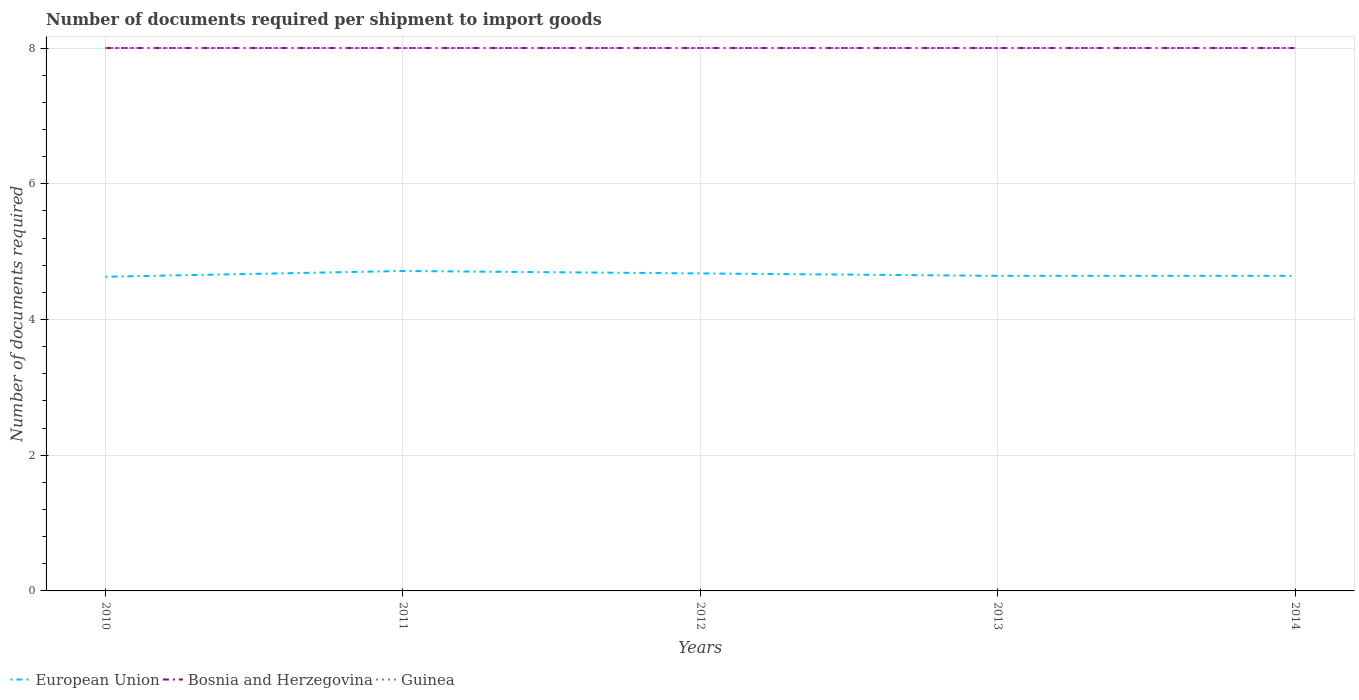Is the number of lines equal to the number of legend labels?
Make the answer very short. Yes. Across all years, what is the maximum number of documents required per shipment to import goods in Guinea?
Your response must be concise. 8. In which year was the number of documents required per shipment to import goods in Bosnia and Herzegovina maximum?
Your response must be concise. 2010. What is the total number of documents required per shipment to import goods in European Union in the graph?
Make the answer very short. -0.01. What is the difference between the highest and the second highest number of documents required per shipment to import goods in Bosnia and Herzegovina?
Offer a terse response. 0. What is the difference between the highest and the lowest number of documents required per shipment to import goods in Bosnia and Herzegovina?
Offer a terse response. 0. Is the number of documents required per shipment to import goods in Bosnia and Herzegovina strictly greater than the number of documents required per shipment to import goods in Guinea over the years?
Provide a succinct answer. No. How many lines are there?
Ensure brevity in your answer.  3. How many years are there in the graph?
Offer a very short reply. 5. What is the difference between two consecutive major ticks on the Y-axis?
Your answer should be very brief. 2. Are the values on the major ticks of Y-axis written in scientific E-notation?
Give a very brief answer. No. Does the graph contain any zero values?
Offer a very short reply. No. Does the graph contain grids?
Make the answer very short. Yes. How many legend labels are there?
Give a very brief answer. 3. How are the legend labels stacked?
Keep it short and to the point. Horizontal. What is the title of the graph?
Offer a very short reply. Number of documents required per shipment to import goods. What is the label or title of the Y-axis?
Keep it short and to the point. Number of documents required. What is the Number of documents required in European Union in 2010?
Ensure brevity in your answer.  4.63. What is the Number of documents required of Bosnia and Herzegovina in 2010?
Keep it short and to the point. 8. What is the Number of documents required of European Union in 2011?
Provide a short and direct response. 4.71. What is the Number of documents required in European Union in 2012?
Give a very brief answer. 4.68. What is the Number of documents required in Guinea in 2012?
Make the answer very short. 8. What is the Number of documents required of European Union in 2013?
Offer a very short reply. 4.64. What is the Number of documents required in Guinea in 2013?
Keep it short and to the point. 8. What is the Number of documents required of European Union in 2014?
Keep it short and to the point. 4.64. What is the Number of documents required in Bosnia and Herzegovina in 2014?
Provide a short and direct response. 8. Across all years, what is the maximum Number of documents required of European Union?
Keep it short and to the point. 4.71. Across all years, what is the maximum Number of documents required in Guinea?
Provide a succinct answer. 8. Across all years, what is the minimum Number of documents required of European Union?
Offer a terse response. 4.63. What is the total Number of documents required of European Union in the graph?
Keep it short and to the point. 23.31. What is the total Number of documents required of Bosnia and Herzegovina in the graph?
Offer a terse response. 40. What is the difference between the Number of documents required of European Union in 2010 and that in 2011?
Keep it short and to the point. -0.08. What is the difference between the Number of documents required in Bosnia and Herzegovina in 2010 and that in 2011?
Make the answer very short. 0. What is the difference between the Number of documents required of European Union in 2010 and that in 2012?
Make the answer very short. -0.05. What is the difference between the Number of documents required in Bosnia and Herzegovina in 2010 and that in 2012?
Keep it short and to the point. 0. What is the difference between the Number of documents required in Guinea in 2010 and that in 2012?
Ensure brevity in your answer.  0. What is the difference between the Number of documents required in European Union in 2010 and that in 2013?
Your answer should be compact. -0.01. What is the difference between the Number of documents required of European Union in 2010 and that in 2014?
Offer a terse response. -0.01. What is the difference between the Number of documents required in Bosnia and Herzegovina in 2010 and that in 2014?
Your answer should be very brief. 0. What is the difference between the Number of documents required in Guinea in 2010 and that in 2014?
Make the answer very short. 0. What is the difference between the Number of documents required in European Union in 2011 and that in 2012?
Offer a terse response. 0.04. What is the difference between the Number of documents required in European Union in 2011 and that in 2013?
Your answer should be very brief. 0.07. What is the difference between the Number of documents required of European Union in 2011 and that in 2014?
Your answer should be very brief. 0.07. What is the difference between the Number of documents required of Guinea in 2011 and that in 2014?
Ensure brevity in your answer.  0. What is the difference between the Number of documents required of European Union in 2012 and that in 2013?
Keep it short and to the point. 0.04. What is the difference between the Number of documents required in Bosnia and Herzegovina in 2012 and that in 2013?
Make the answer very short. 0. What is the difference between the Number of documents required of European Union in 2012 and that in 2014?
Your answer should be very brief. 0.04. What is the difference between the Number of documents required in Bosnia and Herzegovina in 2013 and that in 2014?
Make the answer very short. 0. What is the difference between the Number of documents required in Guinea in 2013 and that in 2014?
Provide a succinct answer. 0. What is the difference between the Number of documents required in European Union in 2010 and the Number of documents required in Bosnia and Herzegovina in 2011?
Keep it short and to the point. -3.37. What is the difference between the Number of documents required in European Union in 2010 and the Number of documents required in Guinea in 2011?
Keep it short and to the point. -3.37. What is the difference between the Number of documents required in Bosnia and Herzegovina in 2010 and the Number of documents required in Guinea in 2011?
Provide a short and direct response. 0. What is the difference between the Number of documents required of European Union in 2010 and the Number of documents required of Bosnia and Herzegovina in 2012?
Provide a short and direct response. -3.37. What is the difference between the Number of documents required in European Union in 2010 and the Number of documents required in Guinea in 2012?
Ensure brevity in your answer.  -3.37. What is the difference between the Number of documents required of European Union in 2010 and the Number of documents required of Bosnia and Herzegovina in 2013?
Offer a terse response. -3.37. What is the difference between the Number of documents required in European Union in 2010 and the Number of documents required in Guinea in 2013?
Ensure brevity in your answer.  -3.37. What is the difference between the Number of documents required in Bosnia and Herzegovina in 2010 and the Number of documents required in Guinea in 2013?
Ensure brevity in your answer.  0. What is the difference between the Number of documents required in European Union in 2010 and the Number of documents required in Bosnia and Herzegovina in 2014?
Offer a very short reply. -3.37. What is the difference between the Number of documents required of European Union in 2010 and the Number of documents required of Guinea in 2014?
Your answer should be very brief. -3.37. What is the difference between the Number of documents required in European Union in 2011 and the Number of documents required in Bosnia and Herzegovina in 2012?
Make the answer very short. -3.29. What is the difference between the Number of documents required of European Union in 2011 and the Number of documents required of Guinea in 2012?
Ensure brevity in your answer.  -3.29. What is the difference between the Number of documents required of European Union in 2011 and the Number of documents required of Bosnia and Herzegovina in 2013?
Offer a very short reply. -3.29. What is the difference between the Number of documents required in European Union in 2011 and the Number of documents required in Guinea in 2013?
Provide a succinct answer. -3.29. What is the difference between the Number of documents required of European Union in 2011 and the Number of documents required of Bosnia and Herzegovina in 2014?
Ensure brevity in your answer.  -3.29. What is the difference between the Number of documents required in European Union in 2011 and the Number of documents required in Guinea in 2014?
Your answer should be compact. -3.29. What is the difference between the Number of documents required of Bosnia and Herzegovina in 2011 and the Number of documents required of Guinea in 2014?
Give a very brief answer. 0. What is the difference between the Number of documents required of European Union in 2012 and the Number of documents required of Bosnia and Herzegovina in 2013?
Offer a terse response. -3.32. What is the difference between the Number of documents required of European Union in 2012 and the Number of documents required of Guinea in 2013?
Provide a short and direct response. -3.32. What is the difference between the Number of documents required of Bosnia and Herzegovina in 2012 and the Number of documents required of Guinea in 2013?
Keep it short and to the point. 0. What is the difference between the Number of documents required in European Union in 2012 and the Number of documents required in Bosnia and Herzegovina in 2014?
Ensure brevity in your answer.  -3.32. What is the difference between the Number of documents required in European Union in 2012 and the Number of documents required in Guinea in 2014?
Your answer should be compact. -3.32. What is the difference between the Number of documents required of Bosnia and Herzegovina in 2012 and the Number of documents required of Guinea in 2014?
Provide a succinct answer. 0. What is the difference between the Number of documents required in European Union in 2013 and the Number of documents required in Bosnia and Herzegovina in 2014?
Ensure brevity in your answer.  -3.36. What is the difference between the Number of documents required of European Union in 2013 and the Number of documents required of Guinea in 2014?
Give a very brief answer. -3.36. What is the average Number of documents required in European Union per year?
Keep it short and to the point. 4.66. What is the average Number of documents required in Bosnia and Herzegovina per year?
Give a very brief answer. 8. What is the average Number of documents required in Guinea per year?
Offer a very short reply. 8. In the year 2010, what is the difference between the Number of documents required in European Union and Number of documents required in Bosnia and Herzegovina?
Give a very brief answer. -3.37. In the year 2010, what is the difference between the Number of documents required in European Union and Number of documents required in Guinea?
Your answer should be very brief. -3.37. In the year 2010, what is the difference between the Number of documents required of Bosnia and Herzegovina and Number of documents required of Guinea?
Ensure brevity in your answer.  0. In the year 2011, what is the difference between the Number of documents required in European Union and Number of documents required in Bosnia and Herzegovina?
Offer a terse response. -3.29. In the year 2011, what is the difference between the Number of documents required in European Union and Number of documents required in Guinea?
Your response must be concise. -3.29. In the year 2011, what is the difference between the Number of documents required of Bosnia and Herzegovina and Number of documents required of Guinea?
Keep it short and to the point. 0. In the year 2012, what is the difference between the Number of documents required of European Union and Number of documents required of Bosnia and Herzegovina?
Give a very brief answer. -3.32. In the year 2012, what is the difference between the Number of documents required in European Union and Number of documents required in Guinea?
Offer a very short reply. -3.32. In the year 2012, what is the difference between the Number of documents required of Bosnia and Herzegovina and Number of documents required of Guinea?
Your response must be concise. 0. In the year 2013, what is the difference between the Number of documents required of European Union and Number of documents required of Bosnia and Herzegovina?
Offer a terse response. -3.36. In the year 2013, what is the difference between the Number of documents required in European Union and Number of documents required in Guinea?
Keep it short and to the point. -3.36. In the year 2013, what is the difference between the Number of documents required of Bosnia and Herzegovina and Number of documents required of Guinea?
Your answer should be compact. 0. In the year 2014, what is the difference between the Number of documents required of European Union and Number of documents required of Bosnia and Herzegovina?
Ensure brevity in your answer.  -3.36. In the year 2014, what is the difference between the Number of documents required of European Union and Number of documents required of Guinea?
Give a very brief answer. -3.36. What is the ratio of the Number of documents required of Bosnia and Herzegovina in 2010 to that in 2011?
Your answer should be very brief. 1. What is the ratio of the Number of documents required of Guinea in 2010 to that in 2011?
Keep it short and to the point. 1. What is the ratio of the Number of documents required of European Union in 2010 to that in 2012?
Keep it short and to the point. 0.99. What is the ratio of the Number of documents required of Bosnia and Herzegovina in 2010 to that in 2012?
Ensure brevity in your answer.  1. What is the ratio of the Number of documents required of Bosnia and Herzegovina in 2010 to that in 2013?
Your answer should be compact. 1. What is the ratio of the Number of documents required of Bosnia and Herzegovina in 2010 to that in 2014?
Keep it short and to the point. 1. What is the ratio of the Number of documents required of European Union in 2011 to that in 2012?
Offer a very short reply. 1.01. What is the ratio of the Number of documents required in Guinea in 2011 to that in 2012?
Your answer should be compact. 1. What is the ratio of the Number of documents required of European Union in 2011 to that in 2013?
Make the answer very short. 1.02. What is the ratio of the Number of documents required of Guinea in 2011 to that in 2013?
Offer a very short reply. 1. What is the ratio of the Number of documents required in European Union in 2011 to that in 2014?
Give a very brief answer. 1.02. What is the ratio of the Number of documents required of European Union in 2012 to that in 2013?
Make the answer very short. 1.01. What is the ratio of the Number of documents required of Guinea in 2012 to that in 2013?
Make the answer very short. 1. What is the ratio of the Number of documents required in European Union in 2012 to that in 2014?
Your response must be concise. 1.01. What is the ratio of the Number of documents required in Guinea in 2012 to that in 2014?
Give a very brief answer. 1. What is the ratio of the Number of documents required of European Union in 2013 to that in 2014?
Your answer should be compact. 1. What is the ratio of the Number of documents required in Bosnia and Herzegovina in 2013 to that in 2014?
Ensure brevity in your answer.  1. What is the ratio of the Number of documents required of Guinea in 2013 to that in 2014?
Offer a terse response. 1. What is the difference between the highest and the second highest Number of documents required in European Union?
Give a very brief answer. 0.04. What is the difference between the highest and the second highest Number of documents required in Bosnia and Herzegovina?
Provide a succinct answer. 0. What is the difference between the highest and the second highest Number of documents required of Guinea?
Offer a terse response. 0. What is the difference between the highest and the lowest Number of documents required in European Union?
Your answer should be very brief. 0.08. What is the difference between the highest and the lowest Number of documents required of Bosnia and Herzegovina?
Your answer should be very brief. 0. What is the difference between the highest and the lowest Number of documents required in Guinea?
Your response must be concise. 0. 